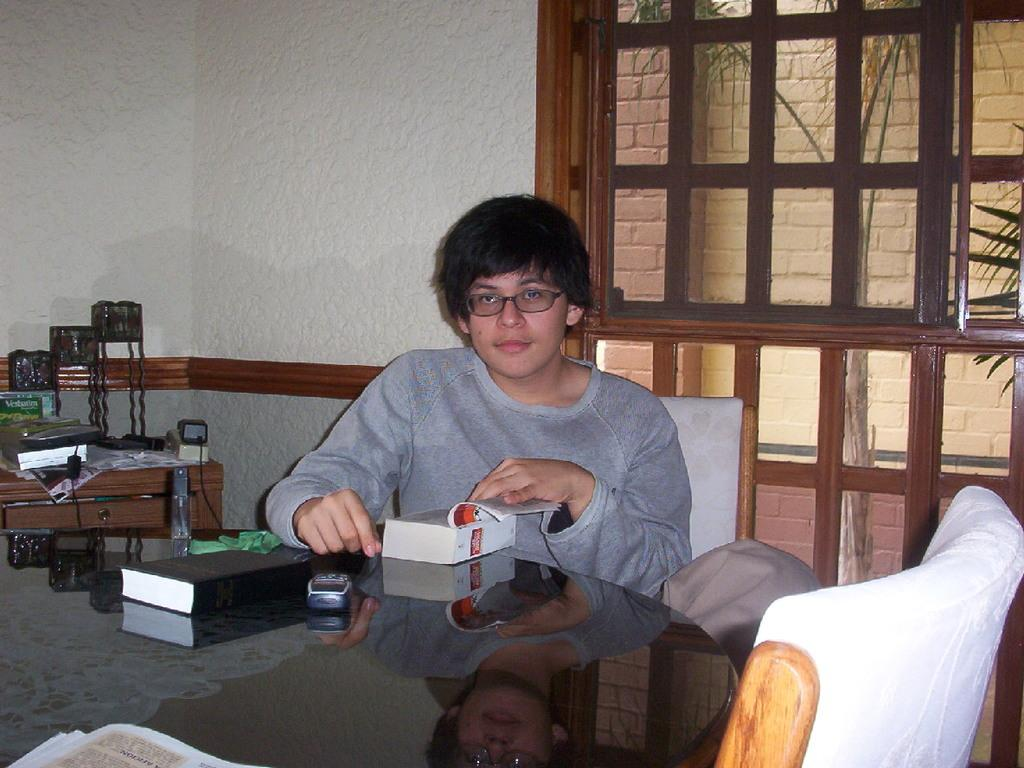Who is the main subject in the image? There is a boy in the image. What is the boy wearing? The boy is wearing a grey t-shirt. Where is the boy sitting? The boy is sitting in front of a table. What objects can be seen on the table? There is a phone, books, and accessories on the table. What is visible on the wall behind the boy? There is a window on the wall behind the boy. What type of seed can be seen growing near the river in the image? There is no seed or river present in the image; it features a boy sitting in front of a table with various objects. Who is the owner of the phone on the table? The image does not provide information about the ownership of the phone, so it cannot be determined from the image. 